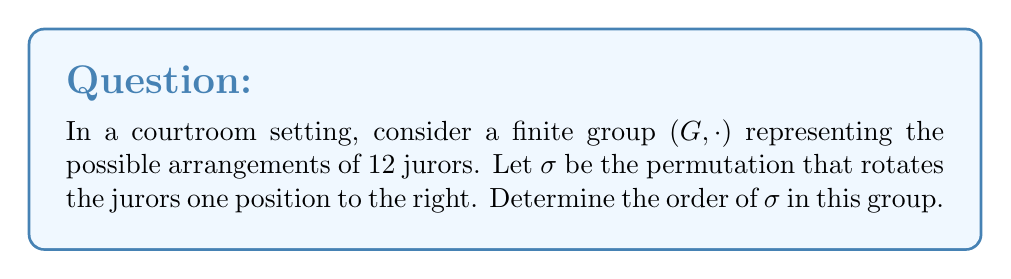Give your solution to this math problem. To determine the order of $\sigma$ in the group, we need to find the smallest positive integer $n$ such that $\sigma^n = e$, where $e$ is the identity element of the group.

Let's approach this step-by-step:

1) First, let's understand what $\sigma$ does:
   $\sigma$ moves each juror one position to the right, with the last juror moving to the first position.

2) Let's see what happens when we apply $\sigma$ multiple times:
   $\sigma^1$: (1 2 3 4 5 6 7 8 9 10 11 12) → (12 1 2 3 4 5 6 7 8 9 10 11)
   $\sigma^2$: (12 1 2 3 4 5 6 7 8 9 10 11) → (11 12 1 2 3 4 5 6 7 8 9 10)
   $\sigma^3$: (11 12 1 2 3 4 5 6 7 8 9 10) → (10 11 12 1 2 3 4 5 6 7 8 9)
   ...

3) We can see that after applying $\sigma$ 12 times, each juror will have moved 12 positions to the right, which is equivalent to not moving at all. In other words:

   $\sigma^{12} = e$

4) This means that the order of $\sigma$ is at most 12. But we need to check if there's a smaller positive integer that also works.

5) Let's consider the factors of 12: 1, 2, 3, 4, 6, 12

6) We can see that $\sigma^1$, $\sigma^2$, $\sigma^3$, $\sigma^4$, and $\sigma^6$ all result in different permutations of the jurors.

Therefore, the smallest positive integer $n$ such that $\sigma^n = e$ is 12.
Answer: The order of $\sigma$ in the group is 12. 